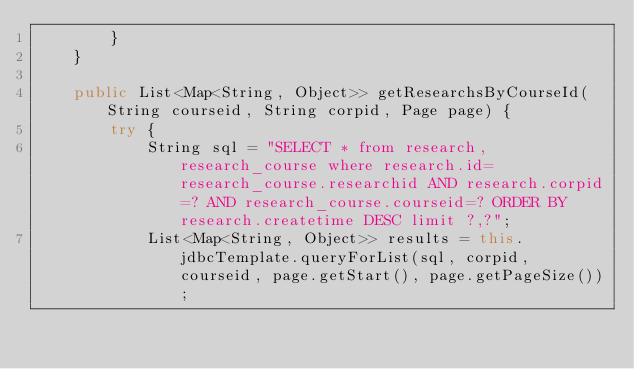<code> <loc_0><loc_0><loc_500><loc_500><_Java_>        }
    }

    public List<Map<String, Object>> getResearchsByCourseId(String courseid, String corpid, Page page) {
        try {
            String sql = "SELECT * from research,research_course where research.id=research_course.researchid AND research.corpid=? AND research_course.courseid=? ORDER BY research.createtime DESC limit ?,?";
            List<Map<String, Object>> results = this.jdbcTemplate.queryForList(sql, corpid, courseid, page.getStart(), page.getPageSize());</code> 